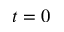Convert formula to latex. <formula><loc_0><loc_0><loc_500><loc_500>t = 0</formula> 